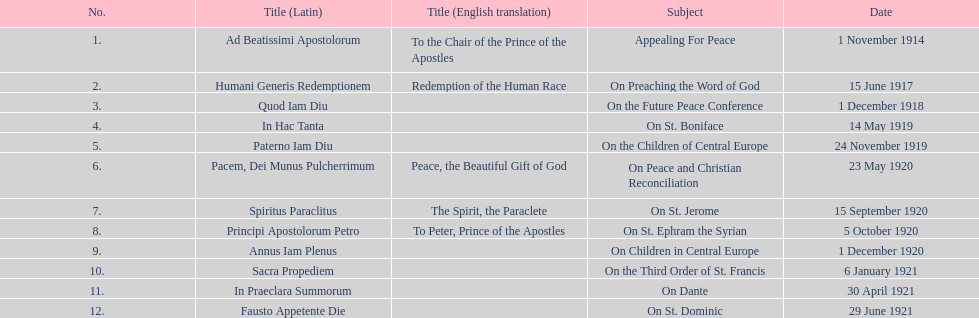How many encyclicals were released in 1921, not counting those in january? 2. 